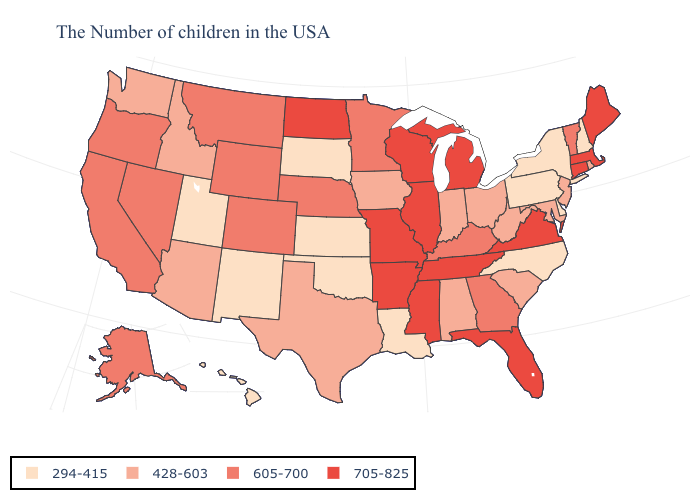Does the first symbol in the legend represent the smallest category?
Write a very short answer. Yes. What is the value of Rhode Island?
Quick response, please. 428-603. What is the highest value in states that border Wyoming?
Short answer required. 605-700. Among the states that border New Mexico , does Oklahoma have the lowest value?
Give a very brief answer. Yes. Among the states that border Wisconsin , which have the lowest value?
Give a very brief answer. Iowa. What is the value of New Hampshire?
Quick response, please. 294-415. What is the lowest value in the Northeast?
Give a very brief answer. 294-415. Is the legend a continuous bar?
Give a very brief answer. No. Among the states that border Tennessee , which have the lowest value?
Quick response, please. North Carolina. What is the value of New Mexico?
Give a very brief answer. 294-415. Name the states that have a value in the range 605-700?
Short answer required. Vermont, Georgia, Kentucky, Minnesota, Nebraska, Wyoming, Colorado, Montana, Nevada, California, Oregon, Alaska. What is the value of South Dakota?
Be succinct. 294-415. What is the value of Washington?
Short answer required. 428-603. Name the states that have a value in the range 605-700?
Write a very short answer. Vermont, Georgia, Kentucky, Minnesota, Nebraska, Wyoming, Colorado, Montana, Nevada, California, Oregon, Alaska. Does Montana have a lower value than Arizona?
Quick response, please. No. 